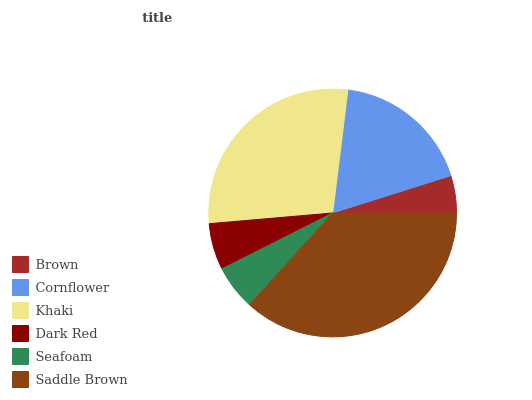Is Brown the minimum?
Answer yes or no. Yes. Is Saddle Brown the maximum?
Answer yes or no. Yes. Is Cornflower the minimum?
Answer yes or no. No. Is Cornflower the maximum?
Answer yes or no. No. Is Cornflower greater than Brown?
Answer yes or no. Yes. Is Brown less than Cornflower?
Answer yes or no. Yes. Is Brown greater than Cornflower?
Answer yes or no. No. Is Cornflower less than Brown?
Answer yes or no. No. Is Cornflower the high median?
Answer yes or no. Yes. Is Dark Red the low median?
Answer yes or no. Yes. Is Saddle Brown the high median?
Answer yes or no. No. Is Saddle Brown the low median?
Answer yes or no. No. 